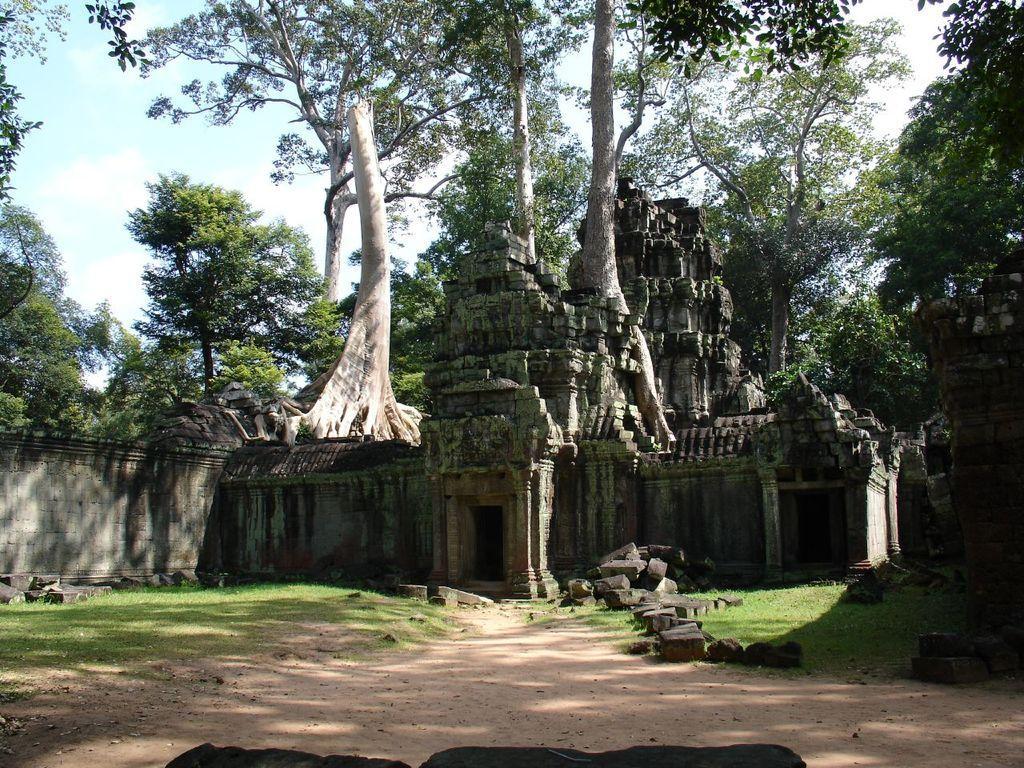Can you describe this image briefly? In this picture we can see a temple, at the bottom there is grass and some rocks, in the background we can see trees, there is the sky at the top of the picture. 